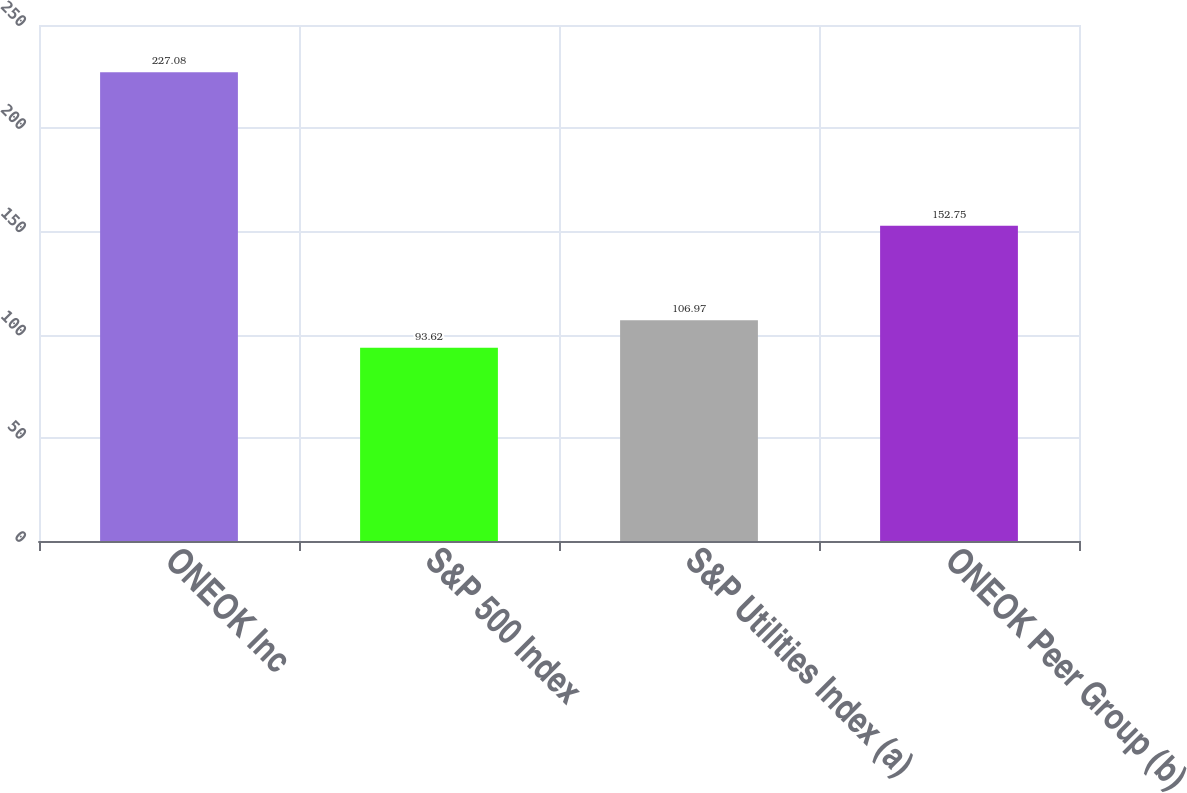Convert chart to OTSL. <chart><loc_0><loc_0><loc_500><loc_500><bar_chart><fcel>ONEOK Inc<fcel>S&P 500 Index<fcel>S&P Utilities Index (a)<fcel>ONEOK Peer Group (b)<nl><fcel>227.08<fcel>93.62<fcel>106.97<fcel>152.75<nl></chart> 